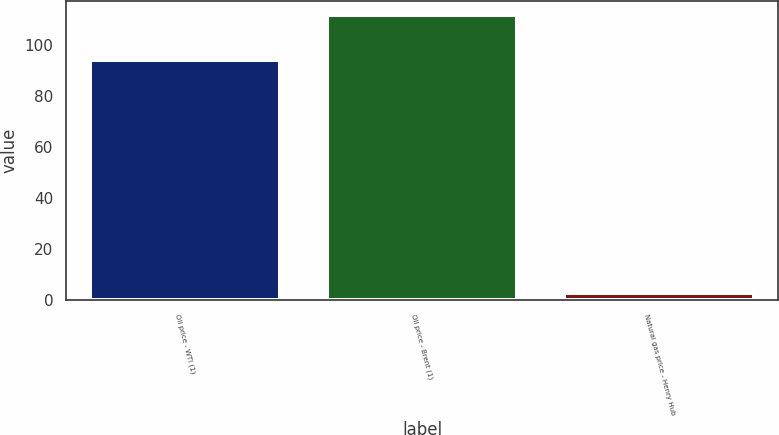Convert chart to OTSL. <chart><loc_0><loc_0><loc_500><loc_500><bar_chart><fcel>Oil price - WTI (1)<fcel>Oil price - Brent (1)<fcel>Natural gas price - Henry Hub<nl><fcel>94.15<fcel>111.6<fcel>2.81<nl></chart> 